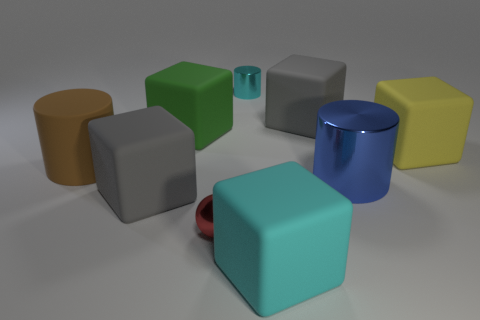Subtract 1 cubes. How many cubes are left? 4 Subtract all yellow cubes. How many cubes are left? 4 Subtract all big yellow rubber cubes. How many cubes are left? 4 Subtract all brown cubes. Subtract all gray spheres. How many cubes are left? 5 Subtract all balls. How many objects are left? 8 Add 7 yellow rubber things. How many yellow rubber things exist? 8 Subtract 0 brown balls. How many objects are left? 9 Subtract all tiny shiny things. Subtract all metal objects. How many objects are left? 4 Add 1 big gray rubber blocks. How many big gray rubber blocks are left? 3 